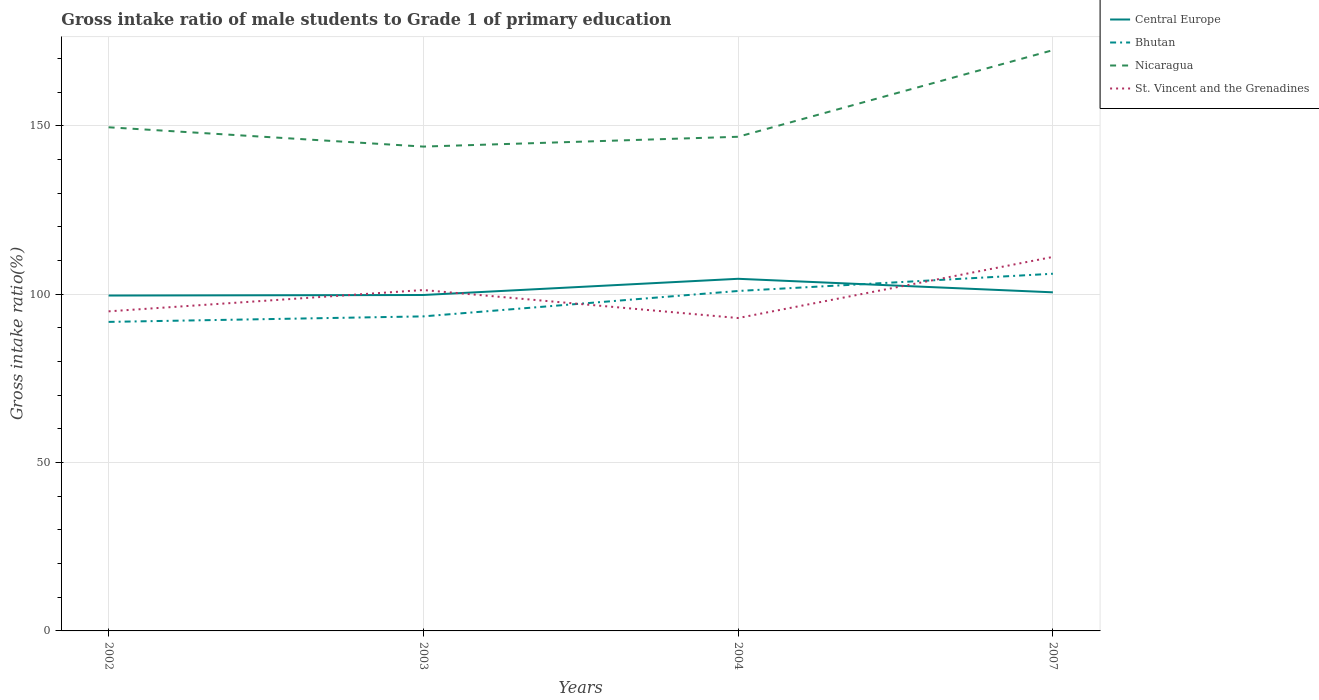Does the line corresponding to Nicaragua intersect with the line corresponding to Central Europe?
Make the answer very short. No. Across all years, what is the maximum gross intake ratio in Central Europe?
Your answer should be compact. 99.63. In which year was the gross intake ratio in St. Vincent and the Grenadines maximum?
Provide a short and direct response. 2004. What is the total gross intake ratio in Nicaragua in the graph?
Provide a short and direct response. -28.65. What is the difference between the highest and the second highest gross intake ratio in Nicaragua?
Ensure brevity in your answer.  28.65. How many lines are there?
Provide a succinct answer. 4. What is the difference between two consecutive major ticks on the Y-axis?
Give a very brief answer. 50. Does the graph contain any zero values?
Your response must be concise. No. Where does the legend appear in the graph?
Offer a very short reply. Top right. How are the legend labels stacked?
Offer a very short reply. Vertical. What is the title of the graph?
Provide a short and direct response. Gross intake ratio of male students to Grade 1 of primary education. What is the label or title of the Y-axis?
Ensure brevity in your answer.  Gross intake ratio(%). What is the Gross intake ratio(%) in Central Europe in 2002?
Keep it short and to the point. 99.63. What is the Gross intake ratio(%) of Bhutan in 2002?
Provide a succinct answer. 91.8. What is the Gross intake ratio(%) in Nicaragua in 2002?
Give a very brief answer. 149.62. What is the Gross intake ratio(%) of St. Vincent and the Grenadines in 2002?
Provide a short and direct response. 94.94. What is the Gross intake ratio(%) in Central Europe in 2003?
Provide a succinct answer. 99.79. What is the Gross intake ratio(%) of Bhutan in 2003?
Your answer should be very brief. 93.44. What is the Gross intake ratio(%) of Nicaragua in 2003?
Offer a very short reply. 143.88. What is the Gross intake ratio(%) of St. Vincent and the Grenadines in 2003?
Your answer should be very brief. 101.27. What is the Gross intake ratio(%) of Central Europe in 2004?
Your response must be concise. 104.61. What is the Gross intake ratio(%) of Bhutan in 2004?
Your answer should be compact. 100.99. What is the Gross intake ratio(%) in Nicaragua in 2004?
Make the answer very short. 146.8. What is the Gross intake ratio(%) of St. Vincent and the Grenadines in 2004?
Keep it short and to the point. 92.95. What is the Gross intake ratio(%) in Central Europe in 2007?
Give a very brief answer. 100.58. What is the Gross intake ratio(%) in Bhutan in 2007?
Provide a short and direct response. 106.11. What is the Gross intake ratio(%) of Nicaragua in 2007?
Offer a very short reply. 172.53. What is the Gross intake ratio(%) of St. Vincent and the Grenadines in 2007?
Keep it short and to the point. 111.1. Across all years, what is the maximum Gross intake ratio(%) in Central Europe?
Provide a succinct answer. 104.61. Across all years, what is the maximum Gross intake ratio(%) of Bhutan?
Provide a succinct answer. 106.11. Across all years, what is the maximum Gross intake ratio(%) of Nicaragua?
Give a very brief answer. 172.53. Across all years, what is the maximum Gross intake ratio(%) of St. Vincent and the Grenadines?
Offer a very short reply. 111.1. Across all years, what is the minimum Gross intake ratio(%) in Central Europe?
Make the answer very short. 99.63. Across all years, what is the minimum Gross intake ratio(%) in Bhutan?
Make the answer very short. 91.8. Across all years, what is the minimum Gross intake ratio(%) in Nicaragua?
Offer a terse response. 143.88. Across all years, what is the minimum Gross intake ratio(%) of St. Vincent and the Grenadines?
Ensure brevity in your answer.  92.95. What is the total Gross intake ratio(%) of Central Europe in the graph?
Provide a short and direct response. 404.62. What is the total Gross intake ratio(%) of Bhutan in the graph?
Give a very brief answer. 392.34. What is the total Gross intake ratio(%) of Nicaragua in the graph?
Provide a succinct answer. 612.82. What is the total Gross intake ratio(%) of St. Vincent and the Grenadines in the graph?
Your response must be concise. 400.26. What is the difference between the Gross intake ratio(%) in Central Europe in 2002 and that in 2003?
Your response must be concise. -0.16. What is the difference between the Gross intake ratio(%) of Bhutan in 2002 and that in 2003?
Offer a very short reply. -1.64. What is the difference between the Gross intake ratio(%) of Nicaragua in 2002 and that in 2003?
Keep it short and to the point. 5.73. What is the difference between the Gross intake ratio(%) in St. Vincent and the Grenadines in 2002 and that in 2003?
Offer a terse response. -6.33. What is the difference between the Gross intake ratio(%) in Central Europe in 2002 and that in 2004?
Your answer should be compact. -4.97. What is the difference between the Gross intake ratio(%) in Bhutan in 2002 and that in 2004?
Provide a short and direct response. -9.18. What is the difference between the Gross intake ratio(%) of Nicaragua in 2002 and that in 2004?
Offer a terse response. 2.82. What is the difference between the Gross intake ratio(%) in St. Vincent and the Grenadines in 2002 and that in 2004?
Offer a very short reply. 1.99. What is the difference between the Gross intake ratio(%) in Central Europe in 2002 and that in 2007?
Provide a short and direct response. -0.95. What is the difference between the Gross intake ratio(%) in Bhutan in 2002 and that in 2007?
Offer a terse response. -14.3. What is the difference between the Gross intake ratio(%) of Nicaragua in 2002 and that in 2007?
Offer a very short reply. -22.91. What is the difference between the Gross intake ratio(%) of St. Vincent and the Grenadines in 2002 and that in 2007?
Offer a very short reply. -16.16. What is the difference between the Gross intake ratio(%) in Central Europe in 2003 and that in 2004?
Offer a terse response. -4.81. What is the difference between the Gross intake ratio(%) in Bhutan in 2003 and that in 2004?
Give a very brief answer. -7.55. What is the difference between the Gross intake ratio(%) in Nicaragua in 2003 and that in 2004?
Offer a terse response. -2.92. What is the difference between the Gross intake ratio(%) in St. Vincent and the Grenadines in 2003 and that in 2004?
Your answer should be very brief. 8.32. What is the difference between the Gross intake ratio(%) in Central Europe in 2003 and that in 2007?
Keep it short and to the point. -0.79. What is the difference between the Gross intake ratio(%) in Bhutan in 2003 and that in 2007?
Provide a short and direct response. -12.66. What is the difference between the Gross intake ratio(%) of Nicaragua in 2003 and that in 2007?
Ensure brevity in your answer.  -28.65. What is the difference between the Gross intake ratio(%) in St. Vincent and the Grenadines in 2003 and that in 2007?
Ensure brevity in your answer.  -9.83. What is the difference between the Gross intake ratio(%) of Central Europe in 2004 and that in 2007?
Provide a succinct answer. 4.02. What is the difference between the Gross intake ratio(%) in Bhutan in 2004 and that in 2007?
Your response must be concise. -5.12. What is the difference between the Gross intake ratio(%) in Nicaragua in 2004 and that in 2007?
Make the answer very short. -25.73. What is the difference between the Gross intake ratio(%) of St. Vincent and the Grenadines in 2004 and that in 2007?
Provide a succinct answer. -18.15. What is the difference between the Gross intake ratio(%) in Central Europe in 2002 and the Gross intake ratio(%) in Bhutan in 2003?
Give a very brief answer. 6.19. What is the difference between the Gross intake ratio(%) of Central Europe in 2002 and the Gross intake ratio(%) of Nicaragua in 2003?
Your answer should be compact. -44.25. What is the difference between the Gross intake ratio(%) in Central Europe in 2002 and the Gross intake ratio(%) in St. Vincent and the Grenadines in 2003?
Ensure brevity in your answer.  -1.63. What is the difference between the Gross intake ratio(%) of Bhutan in 2002 and the Gross intake ratio(%) of Nicaragua in 2003?
Provide a succinct answer. -52.08. What is the difference between the Gross intake ratio(%) of Bhutan in 2002 and the Gross intake ratio(%) of St. Vincent and the Grenadines in 2003?
Offer a terse response. -9.46. What is the difference between the Gross intake ratio(%) of Nicaragua in 2002 and the Gross intake ratio(%) of St. Vincent and the Grenadines in 2003?
Your answer should be very brief. 48.35. What is the difference between the Gross intake ratio(%) of Central Europe in 2002 and the Gross intake ratio(%) of Bhutan in 2004?
Ensure brevity in your answer.  -1.35. What is the difference between the Gross intake ratio(%) of Central Europe in 2002 and the Gross intake ratio(%) of Nicaragua in 2004?
Provide a short and direct response. -47.16. What is the difference between the Gross intake ratio(%) in Central Europe in 2002 and the Gross intake ratio(%) in St. Vincent and the Grenadines in 2004?
Keep it short and to the point. 6.68. What is the difference between the Gross intake ratio(%) in Bhutan in 2002 and the Gross intake ratio(%) in Nicaragua in 2004?
Give a very brief answer. -54.99. What is the difference between the Gross intake ratio(%) of Bhutan in 2002 and the Gross intake ratio(%) of St. Vincent and the Grenadines in 2004?
Your answer should be compact. -1.15. What is the difference between the Gross intake ratio(%) in Nicaragua in 2002 and the Gross intake ratio(%) in St. Vincent and the Grenadines in 2004?
Your response must be concise. 56.67. What is the difference between the Gross intake ratio(%) in Central Europe in 2002 and the Gross intake ratio(%) in Bhutan in 2007?
Give a very brief answer. -6.47. What is the difference between the Gross intake ratio(%) of Central Europe in 2002 and the Gross intake ratio(%) of Nicaragua in 2007?
Give a very brief answer. -72.89. What is the difference between the Gross intake ratio(%) of Central Europe in 2002 and the Gross intake ratio(%) of St. Vincent and the Grenadines in 2007?
Give a very brief answer. -11.47. What is the difference between the Gross intake ratio(%) in Bhutan in 2002 and the Gross intake ratio(%) in Nicaragua in 2007?
Your response must be concise. -80.72. What is the difference between the Gross intake ratio(%) of Bhutan in 2002 and the Gross intake ratio(%) of St. Vincent and the Grenadines in 2007?
Offer a terse response. -19.3. What is the difference between the Gross intake ratio(%) in Nicaragua in 2002 and the Gross intake ratio(%) in St. Vincent and the Grenadines in 2007?
Offer a very short reply. 38.52. What is the difference between the Gross intake ratio(%) in Central Europe in 2003 and the Gross intake ratio(%) in Bhutan in 2004?
Provide a short and direct response. -1.19. What is the difference between the Gross intake ratio(%) of Central Europe in 2003 and the Gross intake ratio(%) of Nicaragua in 2004?
Your answer should be very brief. -47. What is the difference between the Gross intake ratio(%) of Central Europe in 2003 and the Gross intake ratio(%) of St. Vincent and the Grenadines in 2004?
Provide a succinct answer. 6.84. What is the difference between the Gross intake ratio(%) of Bhutan in 2003 and the Gross intake ratio(%) of Nicaragua in 2004?
Make the answer very short. -53.36. What is the difference between the Gross intake ratio(%) in Bhutan in 2003 and the Gross intake ratio(%) in St. Vincent and the Grenadines in 2004?
Provide a short and direct response. 0.49. What is the difference between the Gross intake ratio(%) in Nicaragua in 2003 and the Gross intake ratio(%) in St. Vincent and the Grenadines in 2004?
Provide a short and direct response. 50.93. What is the difference between the Gross intake ratio(%) in Central Europe in 2003 and the Gross intake ratio(%) in Bhutan in 2007?
Offer a terse response. -6.31. What is the difference between the Gross intake ratio(%) in Central Europe in 2003 and the Gross intake ratio(%) in Nicaragua in 2007?
Give a very brief answer. -72.73. What is the difference between the Gross intake ratio(%) of Central Europe in 2003 and the Gross intake ratio(%) of St. Vincent and the Grenadines in 2007?
Offer a very short reply. -11.31. What is the difference between the Gross intake ratio(%) in Bhutan in 2003 and the Gross intake ratio(%) in Nicaragua in 2007?
Offer a very short reply. -79.09. What is the difference between the Gross intake ratio(%) of Bhutan in 2003 and the Gross intake ratio(%) of St. Vincent and the Grenadines in 2007?
Offer a terse response. -17.66. What is the difference between the Gross intake ratio(%) of Nicaragua in 2003 and the Gross intake ratio(%) of St. Vincent and the Grenadines in 2007?
Give a very brief answer. 32.78. What is the difference between the Gross intake ratio(%) of Central Europe in 2004 and the Gross intake ratio(%) of Bhutan in 2007?
Make the answer very short. -1.5. What is the difference between the Gross intake ratio(%) of Central Europe in 2004 and the Gross intake ratio(%) of Nicaragua in 2007?
Your answer should be very brief. -67.92. What is the difference between the Gross intake ratio(%) in Central Europe in 2004 and the Gross intake ratio(%) in St. Vincent and the Grenadines in 2007?
Your answer should be compact. -6.49. What is the difference between the Gross intake ratio(%) of Bhutan in 2004 and the Gross intake ratio(%) of Nicaragua in 2007?
Your answer should be compact. -71.54. What is the difference between the Gross intake ratio(%) in Bhutan in 2004 and the Gross intake ratio(%) in St. Vincent and the Grenadines in 2007?
Make the answer very short. -10.11. What is the difference between the Gross intake ratio(%) in Nicaragua in 2004 and the Gross intake ratio(%) in St. Vincent and the Grenadines in 2007?
Your response must be concise. 35.7. What is the average Gross intake ratio(%) in Central Europe per year?
Ensure brevity in your answer.  101.16. What is the average Gross intake ratio(%) in Bhutan per year?
Ensure brevity in your answer.  98.08. What is the average Gross intake ratio(%) of Nicaragua per year?
Ensure brevity in your answer.  153.21. What is the average Gross intake ratio(%) of St. Vincent and the Grenadines per year?
Offer a very short reply. 100.06. In the year 2002, what is the difference between the Gross intake ratio(%) of Central Europe and Gross intake ratio(%) of Bhutan?
Provide a short and direct response. 7.83. In the year 2002, what is the difference between the Gross intake ratio(%) in Central Europe and Gross intake ratio(%) in Nicaragua?
Offer a terse response. -49.98. In the year 2002, what is the difference between the Gross intake ratio(%) of Central Europe and Gross intake ratio(%) of St. Vincent and the Grenadines?
Your answer should be very brief. 4.7. In the year 2002, what is the difference between the Gross intake ratio(%) in Bhutan and Gross intake ratio(%) in Nicaragua?
Provide a short and direct response. -57.81. In the year 2002, what is the difference between the Gross intake ratio(%) in Bhutan and Gross intake ratio(%) in St. Vincent and the Grenadines?
Your answer should be very brief. -3.13. In the year 2002, what is the difference between the Gross intake ratio(%) in Nicaragua and Gross intake ratio(%) in St. Vincent and the Grenadines?
Make the answer very short. 54.68. In the year 2003, what is the difference between the Gross intake ratio(%) of Central Europe and Gross intake ratio(%) of Bhutan?
Make the answer very short. 6.35. In the year 2003, what is the difference between the Gross intake ratio(%) in Central Europe and Gross intake ratio(%) in Nicaragua?
Your answer should be very brief. -44.09. In the year 2003, what is the difference between the Gross intake ratio(%) in Central Europe and Gross intake ratio(%) in St. Vincent and the Grenadines?
Give a very brief answer. -1.47. In the year 2003, what is the difference between the Gross intake ratio(%) of Bhutan and Gross intake ratio(%) of Nicaragua?
Give a very brief answer. -50.44. In the year 2003, what is the difference between the Gross intake ratio(%) of Bhutan and Gross intake ratio(%) of St. Vincent and the Grenadines?
Give a very brief answer. -7.83. In the year 2003, what is the difference between the Gross intake ratio(%) in Nicaragua and Gross intake ratio(%) in St. Vincent and the Grenadines?
Ensure brevity in your answer.  42.61. In the year 2004, what is the difference between the Gross intake ratio(%) in Central Europe and Gross intake ratio(%) in Bhutan?
Your answer should be compact. 3.62. In the year 2004, what is the difference between the Gross intake ratio(%) of Central Europe and Gross intake ratio(%) of Nicaragua?
Keep it short and to the point. -42.19. In the year 2004, what is the difference between the Gross intake ratio(%) of Central Europe and Gross intake ratio(%) of St. Vincent and the Grenadines?
Your answer should be very brief. 11.66. In the year 2004, what is the difference between the Gross intake ratio(%) in Bhutan and Gross intake ratio(%) in Nicaragua?
Keep it short and to the point. -45.81. In the year 2004, what is the difference between the Gross intake ratio(%) in Bhutan and Gross intake ratio(%) in St. Vincent and the Grenadines?
Give a very brief answer. 8.04. In the year 2004, what is the difference between the Gross intake ratio(%) of Nicaragua and Gross intake ratio(%) of St. Vincent and the Grenadines?
Offer a terse response. 53.85. In the year 2007, what is the difference between the Gross intake ratio(%) of Central Europe and Gross intake ratio(%) of Bhutan?
Your response must be concise. -5.52. In the year 2007, what is the difference between the Gross intake ratio(%) of Central Europe and Gross intake ratio(%) of Nicaragua?
Your answer should be very brief. -71.94. In the year 2007, what is the difference between the Gross intake ratio(%) of Central Europe and Gross intake ratio(%) of St. Vincent and the Grenadines?
Give a very brief answer. -10.52. In the year 2007, what is the difference between the Gross intake ratio(%) of Bhutan and Gross intake ratio(%) of Nicaragua?
Make the answer very short. -66.42. In the year 2007, what is the difference between the Gross intake ratio(%) of Bhutan and Gross intake ratio(%) of St. Vincent and the Grenadines?
Provide a succinct answer. -4.99. In the year 2007, what is the difference between the Gross intake ratio(%) of Nicaragua and Gross intake ratio(%) of St. Vincent and the Grenadines?
Give a very brief answer. 61.43. What is the ratio of the Gross intake ratio(%) in Central Europe in 2002 to that in 2003?
Give a very brief answer. 1. What is the ratio of the Gross intake ratio(%) of Bhutan in 2002 to that in 2003?
Provide a succinct answer. 0.98. What is the ratio of the Gross intake ratio(%) in Nicaragua in 2002 to that in 2003?
Your answer should be compact. 1.04. What is the ratio of the Gross intake ratio(%) of Central Europe in 2002 to that in 2004?
Keep it short and to the point. 0.95. What is the ratio of the Gross intake ratio(%) of Nicaragua in 2002 to that in 2004?
Give a very brief answer. 1.02. What is the ratio of the Gross intake ratio(%) of St. Vincent and the Grenadines in 2002 to that in 2004?
Offer a very short reply. 1.02. What is the ratio of the Gross intake ratio(%) of Central Europe in 2002 to that in 2007?
Make the answer very short. 0.99. What is the ratio of the Gross intake ratio(%) of Bhutan in 2002 to that in 2007?
Offer a terse response. 0.87. What is the ratio of the Gross intake ratio(%) of Nicaragua in 2002 to that in 2007?
Offer a terse response. 0.87. What is the ratio of the Gross intake ratio(%) in St. Vincent and the Grenadines in 2002 to that in 2007?
Your response must be concise. 0.85. What is the ratio of the Gross intake ratio(%) in Central Europe in 2003 to that in 2004?
Your answer should be very brief. 0.95. What is the ratio of the Gross intake ratio(%) of Bhutan in 2003 to that in 2004?
Your response must be concise. 0.93. What is the ratio of the Gross intake ratio(%) of Nicaragua in 2003 to that in 2004?
Offer a very short reply. 0.98. What is the ratio of the Gross intake ratio(%) in St. Vincent and the Grenadines in 2003 to that in 2004?
Your answer should be compact. 1.09. What is the ratio of the Gross intake ratio(%) in Bhutan in 2003 to that in 2007?
Your response must be concise. 0.88. What is the ratio of the Gross intake ratio(%) in Nicaragua in 2003 to that in 2007?
Your answer should be very brief. 0.83. What is the ratio of the Gross intake ratio(%) in St. Vincent and the Grenadines in 2003 to that in 2007?
Offer a terse response. 0.91. What is the ratio of the Gross intake ratio(%) in Bhutan in 2004 to that in 2007?
Make the answer very short. 0.95. What is the ratio of the Gross intake ratio(%) of Nicaragua in 2004 to that in 2007?
Your answer should be very brief. 0.85. What is the ratio of the Gross intake ratio(%) in St. Vincent and the Grenadines in 2004 to that in 2007?
Keep it short and to the point. 0.84. What is the difference between the highest and the second highest Gross intake ratio(%) of Central Europe?
Provide a succinct answer. 4.02. What is the difference between the highest and the second highest Gross intake ratio(%) in Bhutan?
Make the answer very short. 5.12. What is the difference between the highest and the second highest Gross intake ratio(%) in Nicaragua?
Give a very brief answer. 22.91. What is the difference between the highest and the second highest Gross intake ratio(%) of St. Vincent and the Grenadines?
Ensure brevity in your answer.  9.83. What is the difference between the highest and the lowest Gross intake ratio(%) in Central Europe?
Make the answer very short. 4.97. What is the difference between the highest and the lowest Gross intake ratio(%) in Bhutan?
Offer a very short reply. 14.3. What is the difference between the highest and the lowest Gross intake ratio(%) of Nicaragua?
Give a very brief answer. 28.65. What is the difference between the highest and the lowest Gross intake ratio(%) of St. Vincent and the Grenadines?
Your response must be concise. 18.15. 